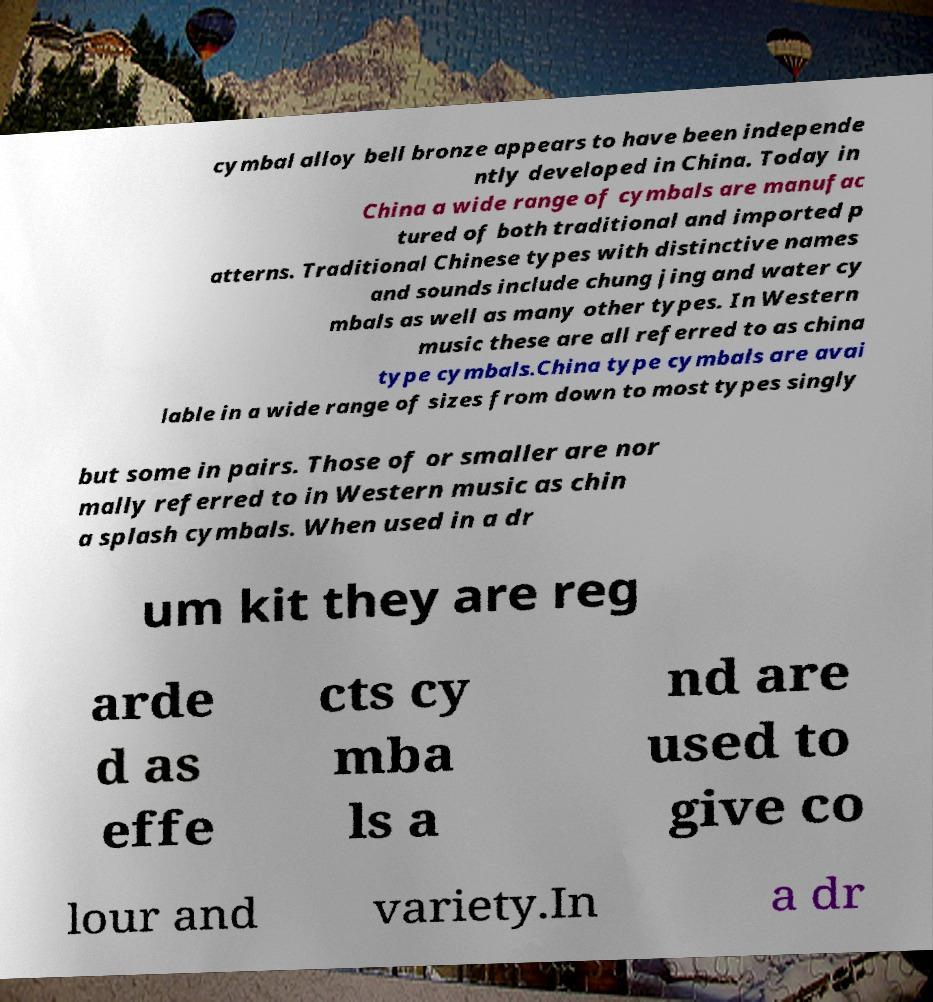Can you read and provide the text displayed in the image?This photo seems to have some interesting text. Can you extract and type it out for me? cymbal alloy bell bronze appears to have been independe ntly developed in China. Today in China a wide range of cymbals are manufac tured of both traditional and imported p atterns. Traditional Chinese types with distinctive names and sounds include chung jing and water cy mbals as well as many other types. In Western music these are all referred to as china type cymbals.China type cymbals are avai lable in a wide range of sizes from down to most types singly but some in pairs. Those of or smaller are nor mally referred to in Western music as chin a splash cymbals. When used in a dr um kit they are reg arde d as effe cts cy mba ls a nd are used to give co lour and variety.In a dr 